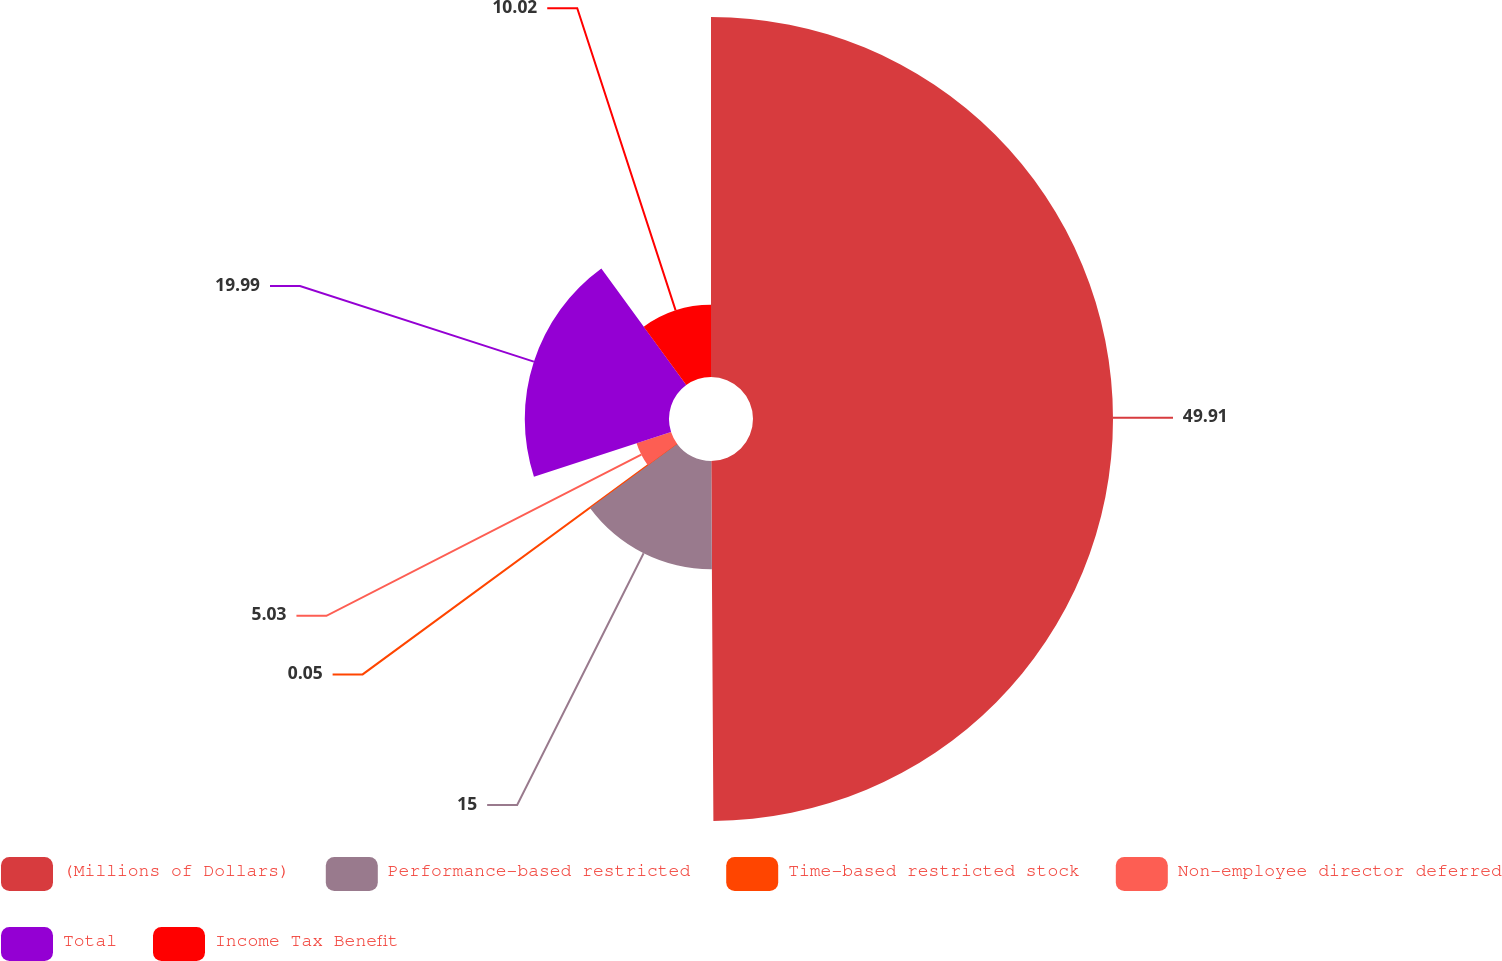<chart> <loc_0><loc_0><loc_500><loc_500><pie_chart><fcel>(Millions of Dollars)<fcel>Performance-based restricted<fcel>Time-based restricted stock<fcel>Non-employee director deferred<fcel>Total<fcel>Income Tax Benefit<nl><fcel>49.9%<fcel>15.0%<fcel>0.05%<fcel>5.03%<fcel>19.99%<fcel>10.02%<nl></chart> 